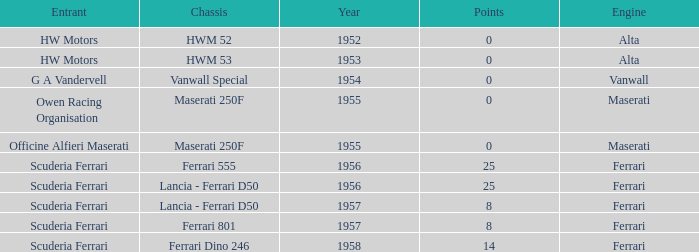What is the most points when Maserati made the engine, and a Entrant of owen racing organisation? 0.0. 